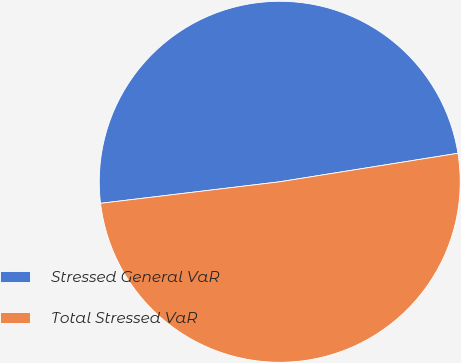Convert chart. <chart><loc_0><loc_0><loc_500><loc_500><pie_chart><fcel>Stressed General VaR<fcel>Total Stressed VaR<nl><fcel>49.38%<fcel>50.62%<nl></chart> 